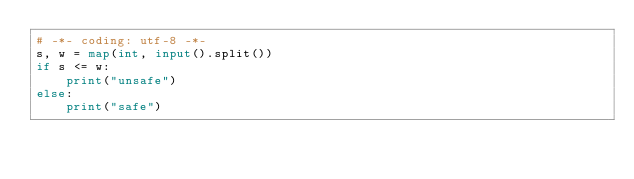Convert code to text. <code><loc_0><loc_0><loc_500><loc_500><_Python_># -*- coding: utf-8 -*-
s, w = map(int, input().split())
if s <= w:
    print("unsafe")
else:
    print("safe")</code> 